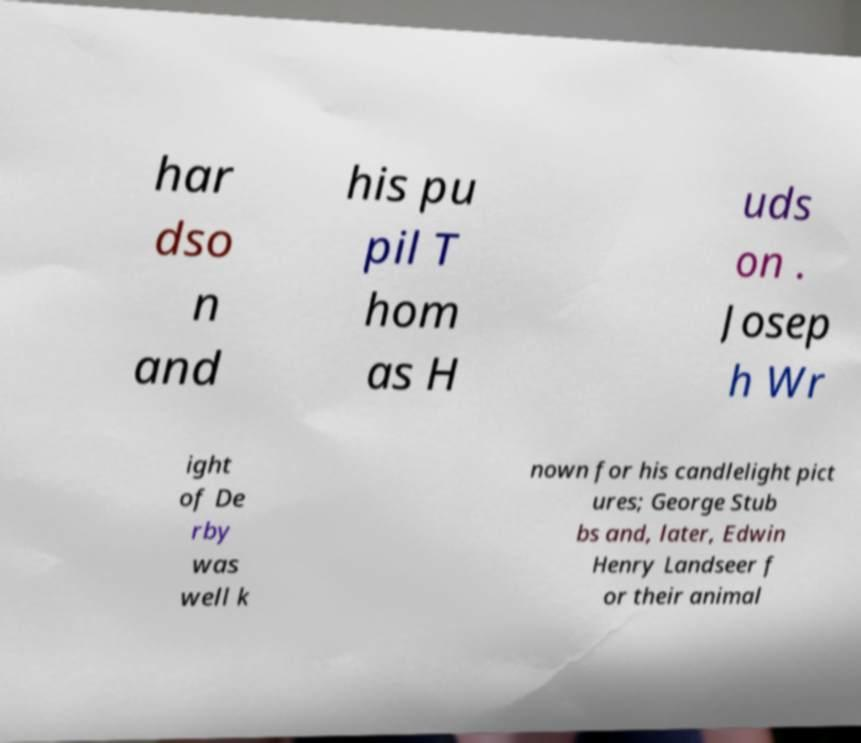Can you read and provide the text displayed in the image?This photo seems to have some interesting text. Can you extract and type it out for me? har dso n and his pu pil T hom as H uds on . Josep h Wr ight of De rby was well k nown for his candlelight pict ures; George Stub bs and, later, Edwin Henry Landseer f or their animal 